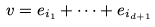Convert formula to latex. <formula><loc_0><loc_0><loc_500><loc_500>v = e _ { i _ { 1 } } + \dots + e _ { i _ { d + 1 } }</formula> 